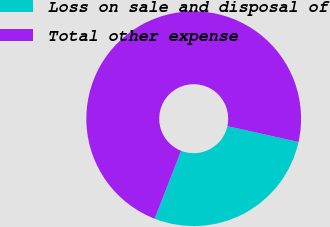Convert chart to OTSL. <chart><loc_0><loc_0><loc_500><loc_500><pie_chart><fcel>Loss on sale and disposal of<fcel>Total other expense<nl><fcel>27.45%<fcel>72.55%<nl></chart> 